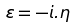<formula> <loc_0><loc_0><loc_500><loc_500>\varepsilon = - i . \eta</formula> 